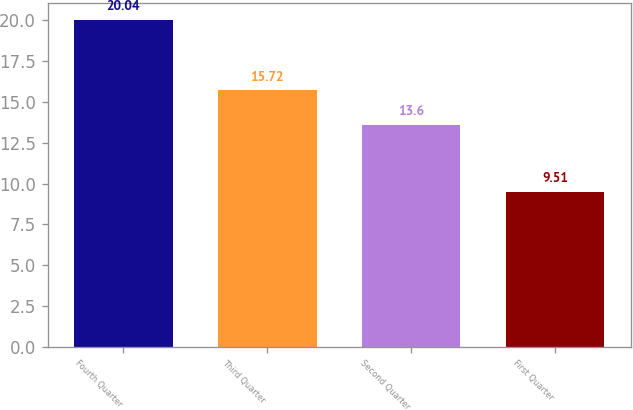<chart> <loc_0><loc_0><loc_500><loc_500><bar_chart><fcel>Fourth Quarter<fcel>Third Quarter<fcel>Second Quarter<fcel>First Quarter<nl><fcel>20.04<fcel>15.72<fcel>13.6<fcel>9.51<nl></chart> 